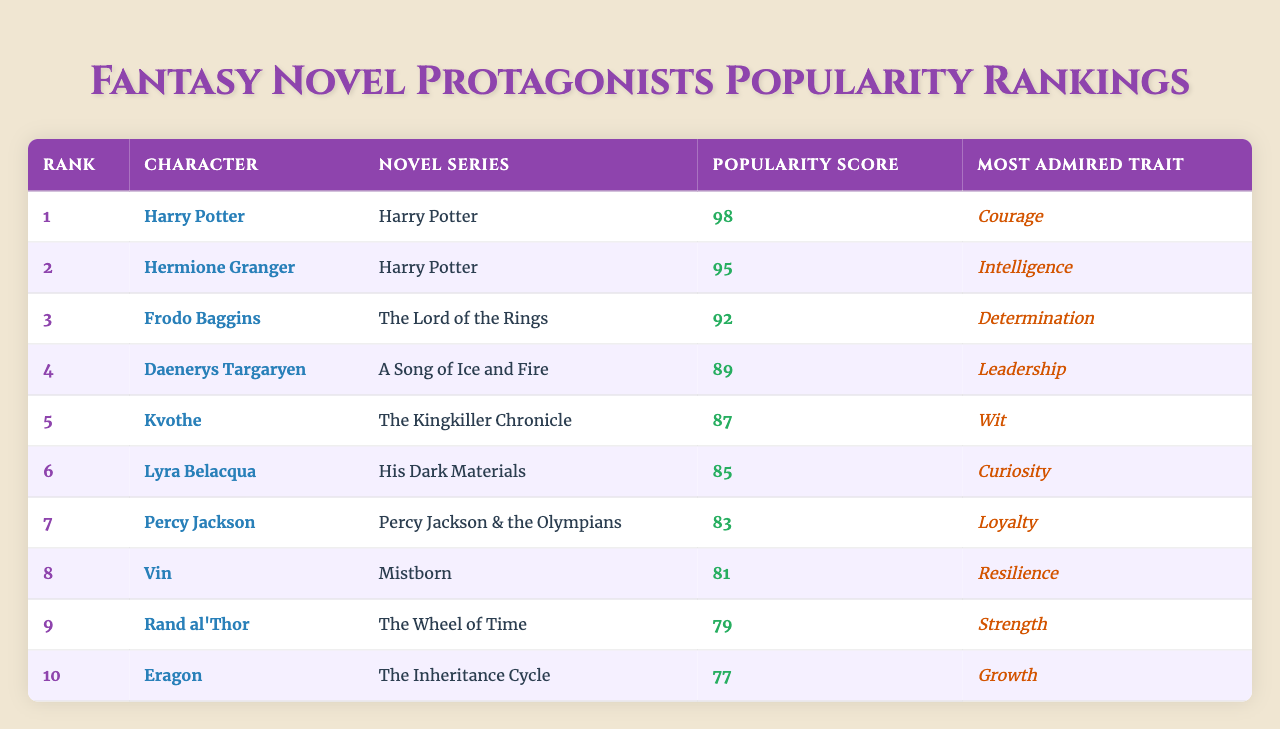What is the most popular character in the table? The character with the highest rank (Rank 1) is Harry Potter, with a popularity score of 98.
Answer: Harry Potter What is the popularity score of Frodo Baggins? Frodo Baggins is ranked 3rd with a popularity score of 92, according to the table.
Answer: 92 Which character from "A Song of Ice and Fire" is listed in the table? The table lists Daenerys Targaryen as the character from "A Song of Ice and Fire," and she is ranked 4th with a score of 89.
Answer: Daenerys Targaryen What is the average popularity score of the top three characters? The scores of the top three characters (98, 95, and 92) are summed up: 98 + 95 + 92 = 285. There are 3 characters, so the average is 285 / 3 = 95.
Answer: 95 Is Eragon ranked higher than Vin? Eragon is ranked 10th (score 77), and Vin is ranked 8th (score 81), meaning Vin is ranked higher than Eragon.
Answer: No Which character has the most admired trait of "Wit"? Kvothe is the character who has "Wit" as his most admired trait, and he is ranked 5th with a score of 87.
Answer: Kvothe How many characters have a popularity score above 80? The characters with scores above 80 are Harry Potter, Hermione Granger, Frodo Baggins, Daenerys Targaryen, Kvothe, Lyra Belacqua, Percy Jackson, and Vin. Counting these characters gives a total of 8.
Answer: 8 What is the combined ranking of Hermione Granger and Percy Jackson? Hermione Granger is ranked 2nd and Percy Jackson is ranked 7th. Their combined ranking calculation is 2 + 7 = 9.
Answer: 9 Which character has the lowest popularity score in the table? The character with the lowest popularity score is Eragon, who is ranked 10th with a score of 77.
Answer: Eragon What is the difference in popularity scores between Harry Potter and Rand al'Thor? Harry Potter has a score of 98 and Rand al'Thor has a score of 79. The difference is calculated as 98 - 79 = 19.
Answer: 19 